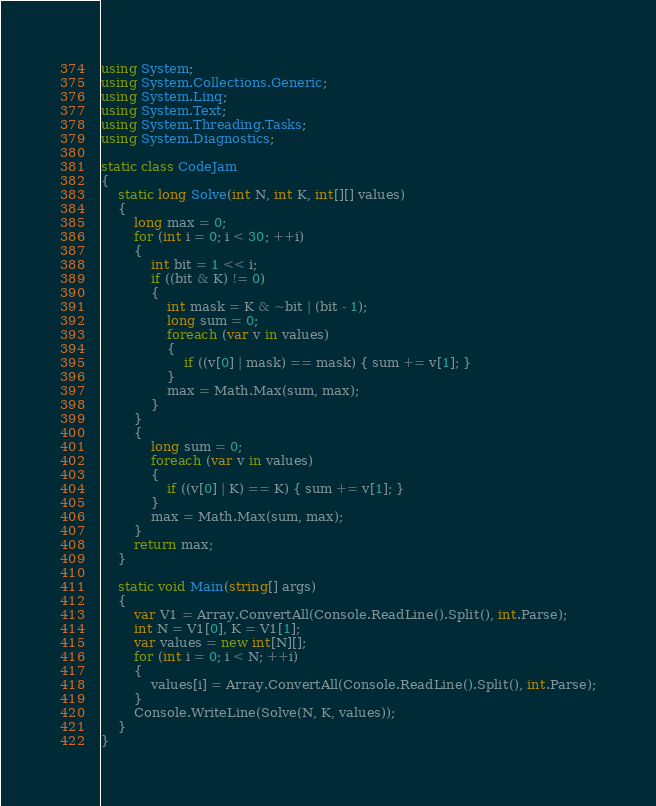Convert code to text. <code><loc_0><loc_0><loc_500><loc_500><_C#_>using System;
using System.Collections.Generic;
using System.Linq;
using System.Text;
using System.Threading.Tasks;
using System.Diagnostics;

static class CodeJam
{
    static long Solve(int N, int K, int[][] values)
    {
        long max = 0;
        for (int i = 0; i < 30; ++i)
        {
            int bit = 1 << i;
            if ((bit & K) != 0)
            {
                int mask = K & ~bit | (bit - 1);
                long sum = 0;
                foreach (var v in values)
                {
                    if ((v[0] | mask) == mask) { sum += v[1]; }
                }
                max = Math.Max(sum, max);
            }
        }
        {
            long sum = 0;
            foreach (var v in values)
            {
                if ((v[0] | K) == K) { sum += v[1]; }
            }
            max = Math.Max(sum, max);
        }
        return max;
    }

    static void Main(string[] args)
    {
        var V1 = Array.ConvertAll(Console.ReadLine().Split(), int.Parse);
        int N = V1[0], K = V1[1];
        var values = new int[N][];
        for (int i = 0; i < N; ++i)
        {
            values[i] = Array.ConvertAll(Console.ReadLine().Split(), int.Parse);
        }
        Console.WriteLine(Solve(N, K, values));
    }
}
</code> 